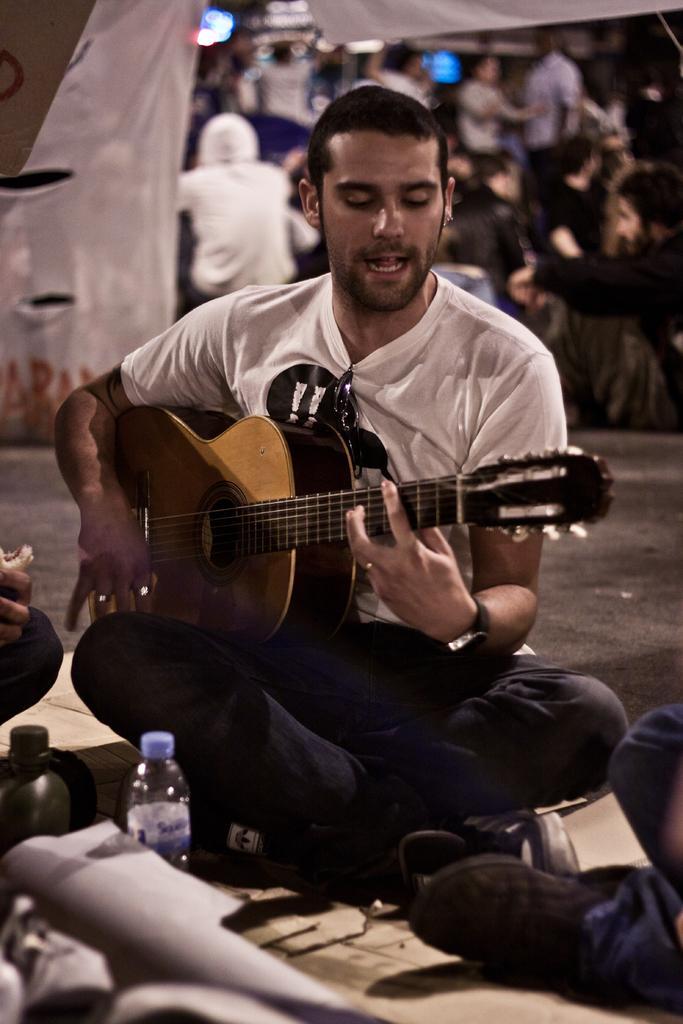Please provide a concise description of this image. A man is sitting on the road and he is playing guitar with his hand ,in front of him there is a bottle and another person. In the background there are many people. 